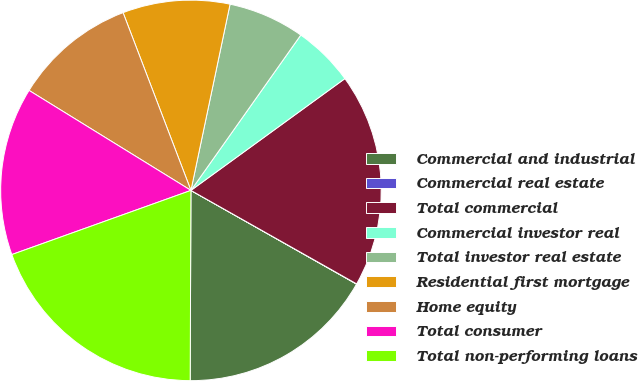<chart> <loc_0><loc_0><loc_500><loc_500><pie_chart><fcel>Commercial and industrial<fcel>Commercial real estate<fcel>Total commercial<fcel>Commercial investor real<fcel>Total investor real estate<fcel>Residential first mortgage<fcel>Home equity<fcel>Total consumer<fcel>Total non-performing loans<nl><fcel>16.87%<fcel>0.02%<fcel>18.17%<fcel>5.21%<fcel>6.5%<fcel>9.1%<fcel>10.39%<fcel>14.28%<fcel>19.46%<nl></chart> 